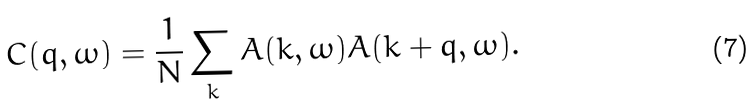<formula> <loc_0><loc_0><loc_500><loc_500>C ( { q } , \omega ) = \frac { 1 } { N } \sum _ { k } A ( { k } , \omega ) A ( { k } + { q } , \omega ) .</formula> 